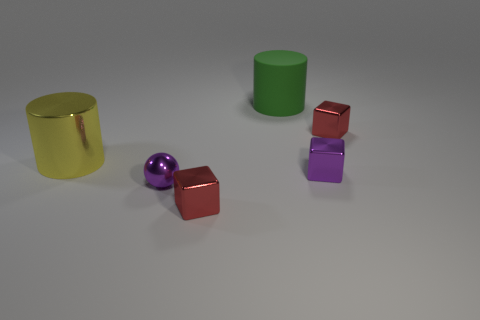Add 2 large brown metal things. How many objects exist? 8 Subtract all cylinders. How many objects are left? 4 Subtract all big green rubber objects. Subtract all tiny purple cubes. How many objects are left? 4 Add 1 large green rubber objects. How many large green rubber objects are left? 2 Add 6 green metal blocks. How many green metal blocks exist? 6 Subtract 0 purple cylinders. How many objects are left? 6 